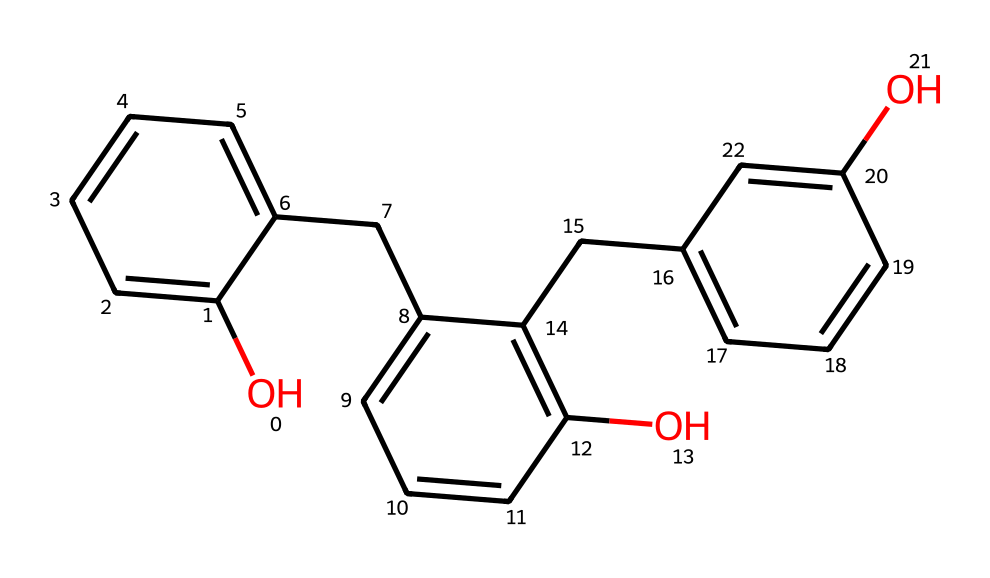What is the main functional group present in this chemical structure? The displayed structure prominently features hydroxyl (–OH) groups, which are characteristic of phenols.
Answer: hydroxyl How many aromatic rings are present in this molecule? By analyzing the structure, there are three distinct aromatic rings in the compound, which can be identified by the alternating double bonds and the cyclic nature typical of aromatic systems.
Answer: three What type of resin does this chemical represent? The molecular structure exhibits characteristics of phenol-formaldehyde novolac resins, commonly used in high-resolution photoresists, which are produced via the polymerization of phenols with formaldehyde under specific conditions.
Answer: novolac What is the total number of carbon atoms in this chemical? Counting the carbon atoms present in the entire structure reveals a total of 21 carbon atoms, accounting for all parts of the aromatic rings and the linking chains.
Answer: twenty-one Does this structure contain any oxygen atoms? If so, how many? Upon examining the structure, the compound includes several oxygen atoms, specifically those found in the hydroxyl groups and as part of the ether functionalities, totaling 6 oxygen atoms.
Answer: six What property of this chemical makes it suitable for use in photoresists? This compound's stable structure and ability to undergo cross-linking upon exposure to light make it ideal for photoresist applications, leading to high resolution and durability in lithography processes.
Answer: stability 